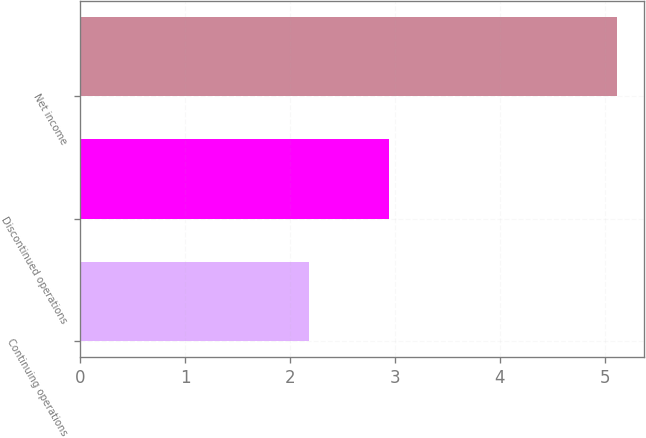Convert chart to OTSL. <chart><loc_0><loc_0><loc_500><loc_500><bar_chart><fcel>Continuing operations<fcel>Discontinued operations<fcel>Net income<nl><fcel>2.18<fcel>2.94<fcel>5.12<nl></chart> 